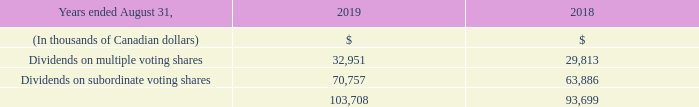C) DIVIDENDS
For the year ended August 31, 2019, quarterly eligible dividends of $0.525 per share, for a total of $2.10 per share or $103.7 million, were paid to the holders of multiple and subordinate voting shares, compared to quarterly eligible dividends of $0.475 per share, for a total of $1.90 per share or $93.7 million for the year ended August 31, 2018.
At its October 30, 2019 meeting, the Board of Directors of Cogeco Communications declared a quarterly eligible dividend of $0.58 per share for multiple voting and subordinate voting shares, payable on November 27, 2019 to shareholders of record on November 13, 2019.
What was the eligible quarterly dividends in August 2019? $0.525. What was the eligible quarterly dividends in August 2018? $0.475. What was the declared quarterly dividend for multiple voting and subordinate voting shares in 2019? $0.58. What was the increase / (decrease) in the Dividends on multiple voting shares from 2018 to 2019?
Answer scale should be: thousand. 32,951 - 29,813
Answer: 3138. What was the average Dividends on subordinate voting shares from 2018 to 2019?
Answer scale should be: thousand. (70,757 + 63,886) / 2
Answer: 67321.5. What was the average Dividends on multiple voting shares from 2018 to 2019?
Answer scale should be: thousand. (32,951 + 29,813) / 2
Answer: 31382. 